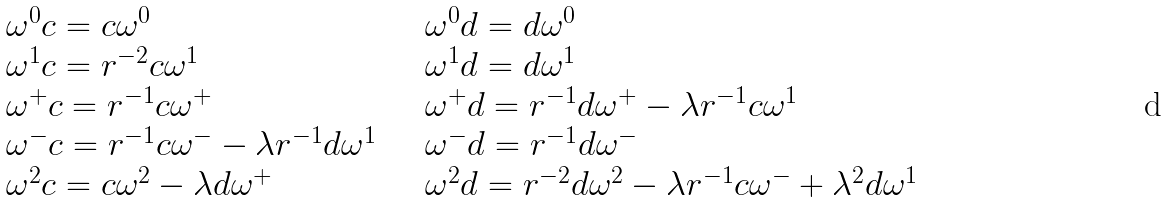Convert formula to latex. <formula><loc_0><loc_0><loc_500><loc_500>\begin{array} { l l } \omega ^ { 0 } c = c \omega ^ { 0 } & \quad \omega ^ { 0 } d = d \omega ^ { 0 } \\ \omega ^ { 1 } c = r ^ { - 2 } c \omega ^ { 1 } & \quad \omega ^ { 1 } d = d \omega ^ { 1 } \\ \omega ^ { + } c = r ^ { - 1 } c \omega ^ { + } & \quad \omega ^ { + } d = r ^ { - 1 } d \omega ^ { + } - \lambda r ^ { - 1 } c \omega ^ { 1 } \\ \omega ^ { - } c = r ^ { - 1 } c \omega ^ { - } - \lambda r ^ { - 1 } d \omega ^ { 1 } & \quad \omega ^ { - } d = r ^ { - 1 } d \omega ^ { - } \\ \omega ^ { 2 } c = c \omega ^ { 2 } - \lambda d \omega ^ { + } & \quad \omega ^ { 2 } d = r ^ { - 2 } d \omega ^ { 2 } - \lambda r ^ { - 1 } c \omega ^ { - } + \lambda ^ { 2 } d \omega ^ { 1 } \end{array}</formula> 